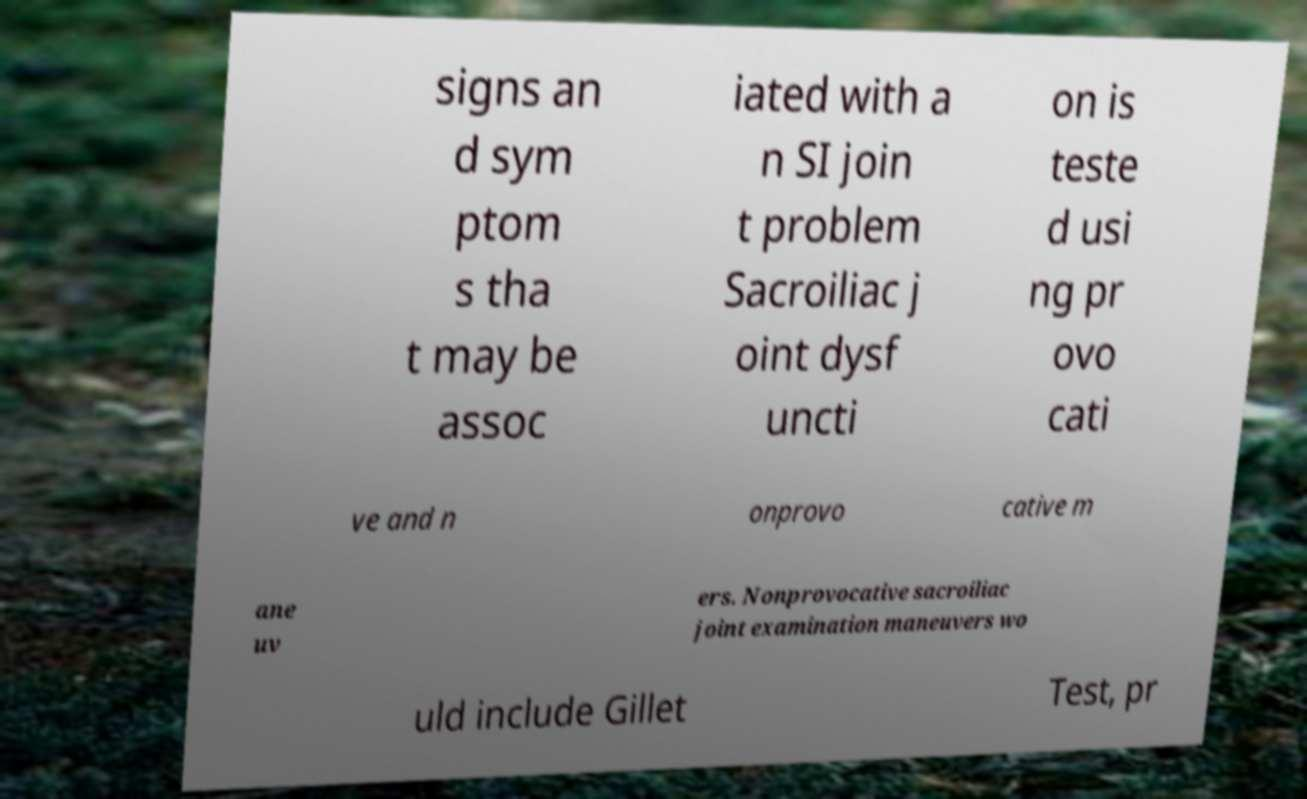Could you assist in decoding the text presented in this image and type it out clearly? signs an d sym ptom s tha t may be assoc iated with a n SI join t problem Sacroiliac j oint dysf uncti on is teste d usi ng pr ovo cati ve and n onprovo cative m ane uv ers. Nonprovocative sacroiliac joint examination maneuvers wo uld include Gillet Test, pr 